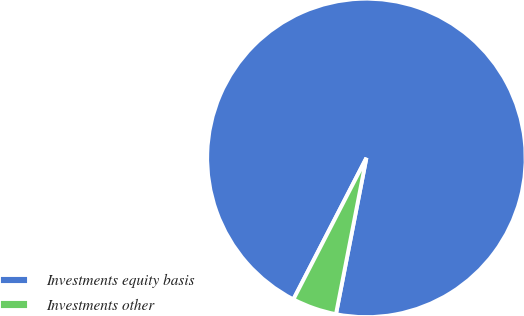Convert chart. <chart><loc_0><loc_0><loc_500><loc_500><pie_chart><fcel>Investments equity basis<fcel>Investments other<nl><fcel>95.48%<fcel>4.52%<nl></chart> 